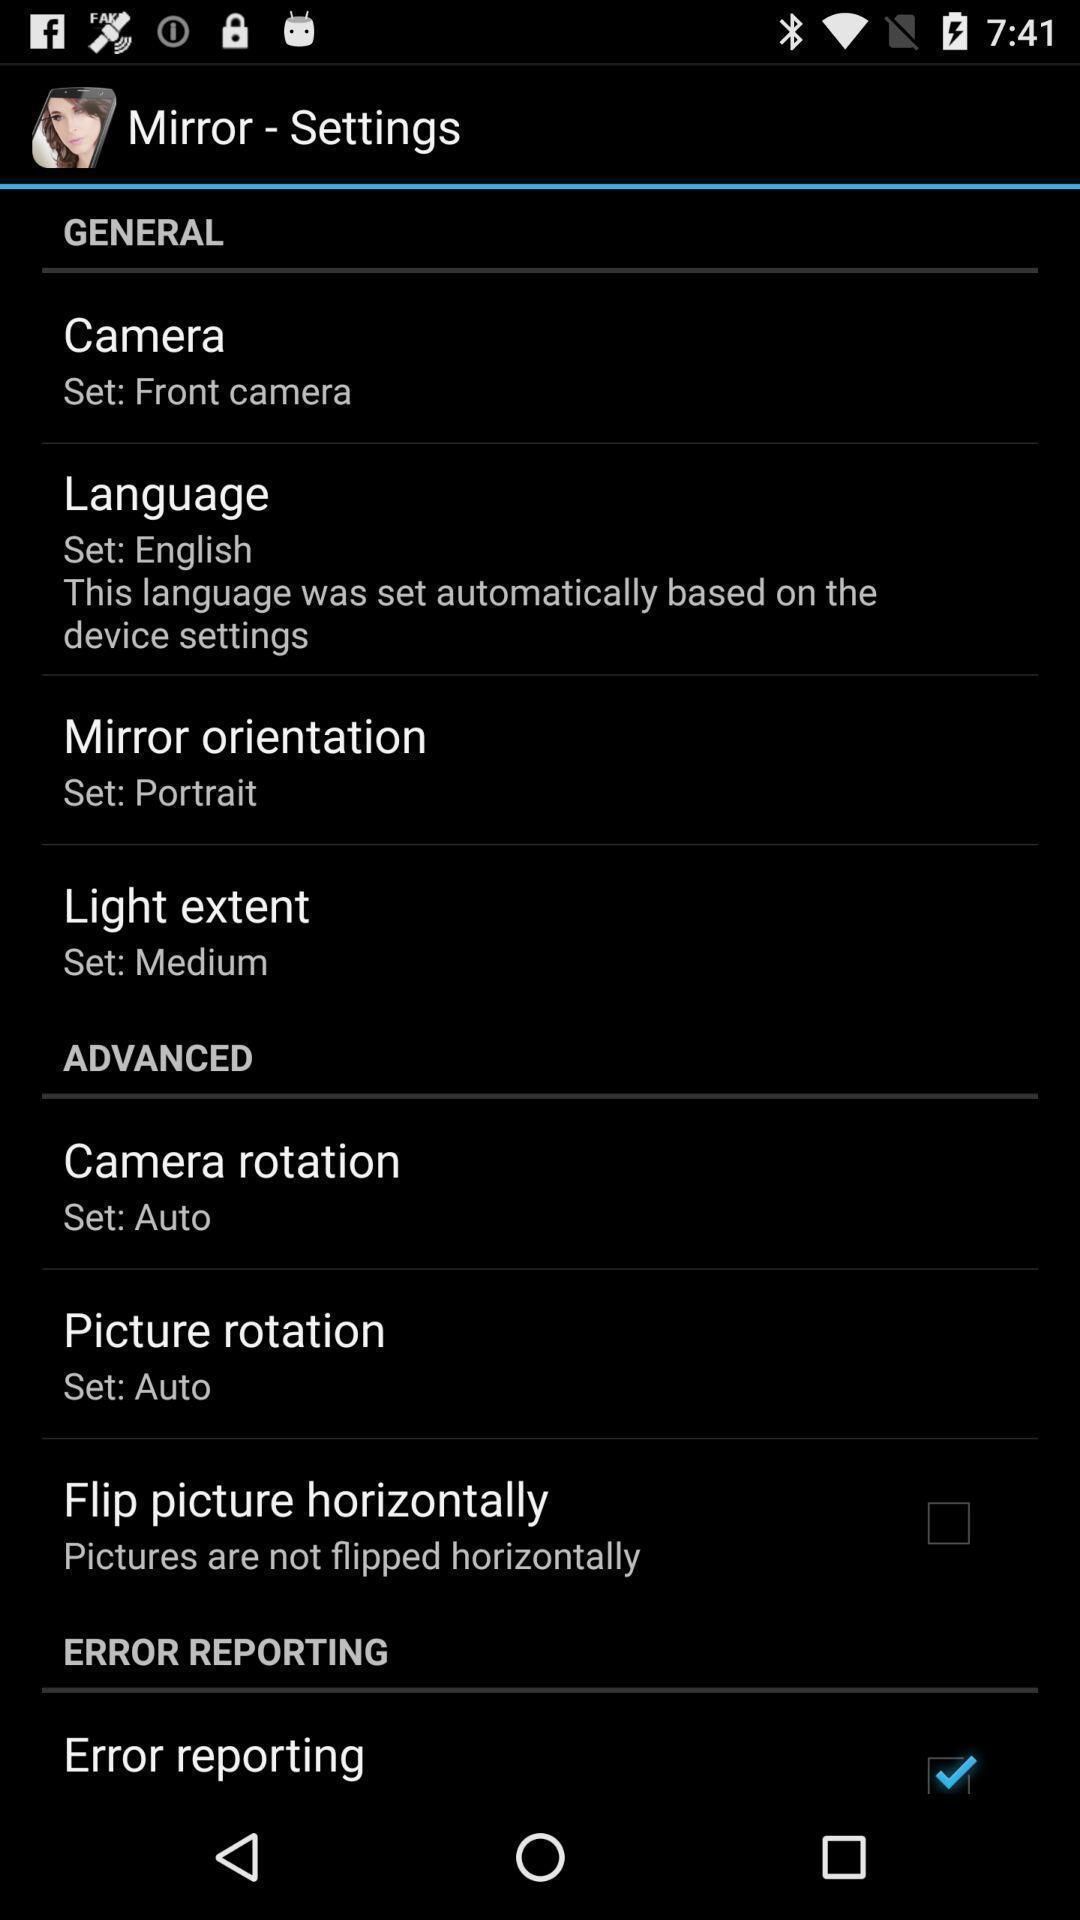Describe the key features of this screenshot. Settings of a list of camera app. 